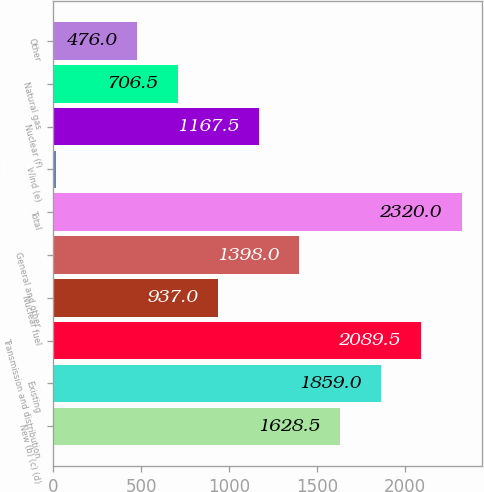Convert chart to OTSL. <chart><loc_0><loc_0><loc_500><loc_500><bar_chart><fcel>New (b) (c) (d)<fcel>Existing<fcel>Transmission and distribution<fcel>Nuclear fuel<fcel>General and other<fcel>Total<fcel>Wind (e)<fcel>Nuclear (f)<fcel>Natural gas<fcel>Other<nl><fcel>1628.5<fcel>1859<fcel>2089.5<fcel>937<fcel>1398<fcel>2320<fcel>15<fcel>1167.5<fcel>706.5<fcel>476<nl></chart> 